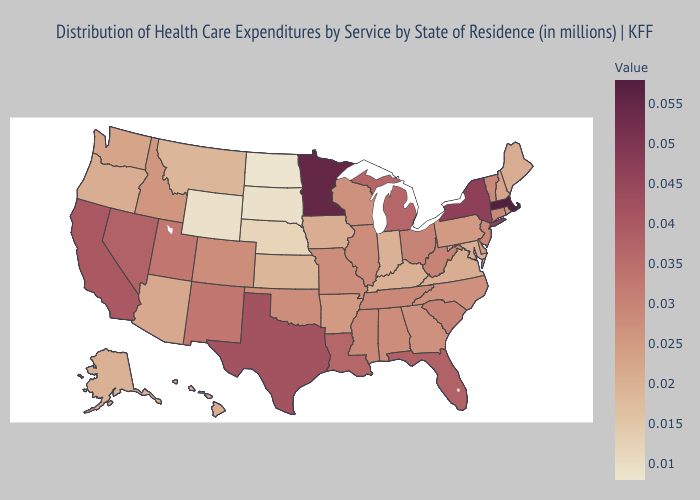Does North Carolina have the lowest value in the USA?
Write a very short answer. No. Does New Jersey have the lowest value in the Northeast?
Write a very short answer. No. Is the legend a continuous bar?
Concise answer only. Yes. Which states hav the highest value in the MidWest?
Concise answer only. Minnesota. Is the legend a continuous bar?
Answer briefly. Yes. 